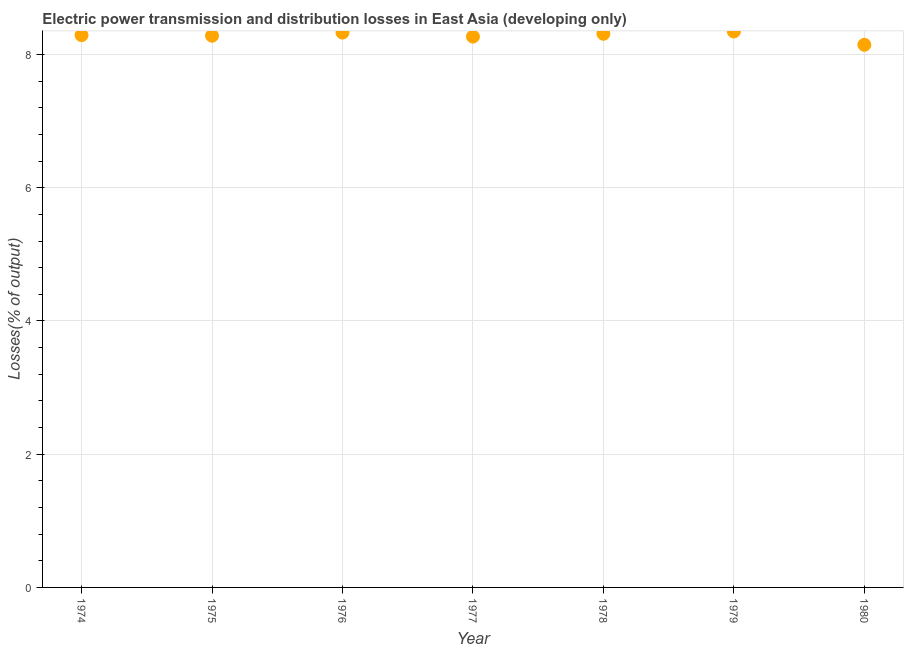What is the electric power transmission and distribution losses in 1976?
Your response must be concise. 8.33. Across all years, what is the maximum electric power transmission and distribution losses?
Provide a succinct answer. 8.35. Across all years, what is the minimum electric power transmission and distribution losses?
Make the answer very short. 8.15. In which year was the electric power transmission and distribution losses maximum?
Your response must be concise. 1979. What is the sum of the electric power transmission and distribution losses?
Provide a short and direct response. 57.98. What is the difference between the electric power transmission and distribution losses in 1978 and 1980?
Provide a short and direct response. 0.17. What is the average electric power transmission and distribution losses per year?
Provide a succinct answer. 8.28. What is the median electric power transmission and distribution losses?
Your answer should be compact. 8.29. In how many years, is the electric power transmission and distribution losses greater than 5.6 %?
Your response must be concise. 7. What is the ratio of the electric power transmission and distribution losses in 1977 to that in 1979?
Your answer should be very brief. 0.99. Is the difference between the electric power transmission and distribution losses in 1974 and 1976 greater than the difference between any two years?
Your answer should be compact. No. What is the difference between the highest and the second highest electric power transmission and distribution losses?
Your response must be concise. 0.02. What is the difference between the highest and the lowest electric power transmission and distribution losses?
Keep it short and to the point. 0.2. In how many years, is the electric power transmission and distribution losses greater than the average electric power transmission and distribution losses taken over all years?
Your response must be concise. 5. How many dotlines are there?
Keep it short and to the point. 1. How many years are there in the graph?
Offer a very short reply. 7. Does the graph contain any zero values?
Provide a succinct answer. No. What is the title of the graph?
Provide a short and direct response. Electric power transmission and distribution losses in East Asia (developing only). What is the label or title of the Y-axis?
Make the answer very short. Losses(% of output). What is the Losses(% of output) in 1974?
Provide a short and direct response. 8.29. What is the Losses(% of output) in 1975?
Provide a short and direct response. 8.28. What is the Losses(% of output) in 1976?
Keep it short and to the point. 8.33. What is the Losses(% of output) in 1977?
Make the answer very short. 8.27. What is the Losses(% of output) in 1978?
Give a very brief answer. 8.31. What is the Losses(% of output) in 1979?
Your response must be concise. 8.35. What is the Losses(% of output) in 1980?
Keep it short and to the point. 8.15. What is the difference between the Losses(% of output) in 1974 and 1975?
Keep it short and to the point. 0.01. What is the difference between the Losses(% of output) in 1974 and 1976?
Give a very brief answer. -0.04. What is the difference between the Losses(% of output) in 1974 and 1977?
Your response must be concise. 0.02. What is the difference between the Losses(% of output) in 1974 and 1978?
Keep it short and to the point. -0.02. What is the difference between the Losses(% of output) in 1974 and 1979?
Your answer should be very brief. -0.05. What is the difference between the Losses(% of output) in 1974 and 1980?
Ensure brevity in your answer.  0.14. What is the difference between the Losses(% of output) in 1975 and 1976?
Ensure brevity in your answer.  -0.05. What is the difference between the Losses(% of output) in 1975 and 1977?
Your response must be concise. 0.01. What is the difference between the Losses(% of output) in 1975 and 1978?
Make the answer very short. -0.03. What is the difference between the Losses(% of output) in 1975 and 1979?
Your answer should be very brief. -0.06. What is the difference between the Losses(% of output) in 1975 and 1980?
Ensure brevity in your answer.  0.14. What is the difference between the Losses(% of output) in 1976 and 1977?
Your answer should be very brief. 0.06. What is the difference between the Losses(% of output) in 1976 and 1978?
Your answer should be very brief. 0.02. What is the difference between the Losses(% of output) in 1976 and 1979?
Ensure brevity in your answer.  -0.02. What is the difference between the Losses(% of output) in 1976 and 1980?
Offer a terse response. 0.18. What is the difference between the Losses(% of output) in 1977 and 1978?
Your response must be concise. -0.04. What is the difference between the Losses(% of output) in 1977 and 1979?
Provide a short and direct response. -0.08. What is the difference between the Losses(% of output) in 1977 and 1980?
Offer a terse response. 0.12. What is the difference between the Losses(% of output) in 1978 and 1979?
Ensure brevity in your answer.  -0.03. What is the difference between the Losses(% of output) in 1978 and 1980?
Make the answer very short. 0.17. What is the difference between the Losses(% of output) in 1979 and 1980?
Offer a terse response. 0.2. What is the ratio of the Losses(% of output) in 1974 to that in 1975?
Your answer should be very brief. 1. What is the ratio of the Losses(% of output) in 1974 to that in 1976?
Ensure brevity in your answer.  0.99. What is the ratio of the Losses(% of output) in 1974 to that in 1977?
Offer a terse response. 1. What is the ratio of the Losses(% of output) in 1974 to that in 1978?
Offer a terse response. 1. What is the ratio of the Losses(% of output) in 1974 to that in 1979?
Your answer should be very brief. 0.99. What is the ratio of the Losses(% of output) in 1975 to that in 1978?
Provide a succinct answer. 1. What is the ratio of the Losses(% of output) in 1975 to that in 1980?
Ensure brevity in your answer.  1.02. What is the ratio of the Losses(% of output) in 1976 to that in 1979?
Offer a very short reply. 1. What is the ratio of the Losses(% of output) in 1977 to that in 1978?
Your answer should be compact. 0.99. What is the ratio of the Losses(% of output) in 1978 to that in 1979?
Offer a terse response. 1. What is the ratio of the Losses(% of output) in 1978 to that in 1980?
Provide a succinct answer. 1.02. What is the ratio of the Losses(% of output) in 1979 to that in 1980?
Make the answer very short. 1.02. 